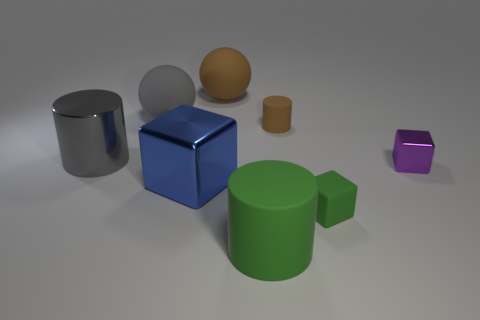Add 1 small yellow rubber cubes. How many objects exist? 9 Subtract all cylinders. How many objects are left? 5 Add 7 big green matte cylinders. How many big green matte cylinders are left? 8 Add 7 large blue things. How many large blue things exist? 8 Subtract 0 blue cylinders. How many objects are left? 8 Subtract all small green blocks. Subtract all small green things. How many objects are left? 6 